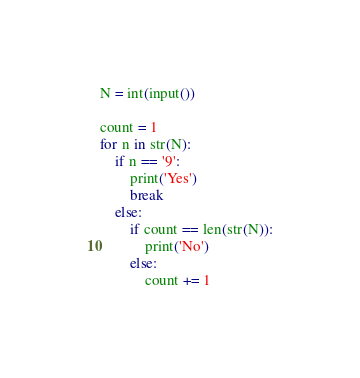<code> <loc_0><loc_0><loc_500><loc_500><_Python_>N = int(input())

count = 1
for n in str(N):
    if n == '9':
        print('Yes')
        break
    else:
        if count == len(str(N)):
            print('No')
        else:
            count += 1
</code> 